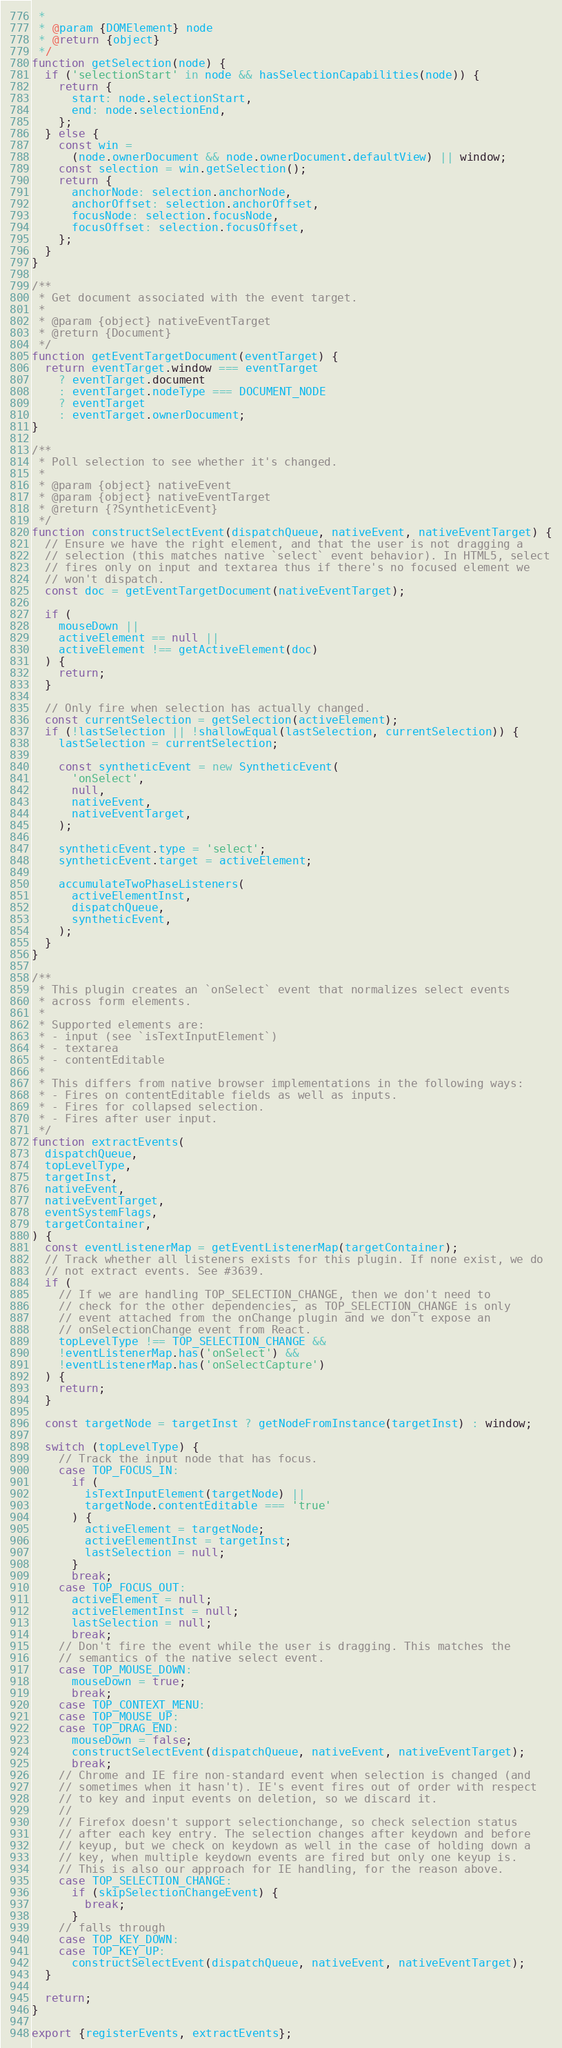Convert code to text. <code><loc_0><loc_0><loc_500><loc_500><_JavaScript_> *
 * @param {DOMElement} node
 * @return {object}
 */
function getSelection(node) {
  if ('selectionStart' in node && hasSelectionCapabilities(node)) {
    return {
      start: node.selectionStart,
      end: node.selectionEnd,
    };
  } else {
    const win =
      (node.ownerDocument && node.ownerDocument.defaultView) || window;
    const selection = win.getSelection();
    return {
      anchorNode: selection.anchorNode,
      anchorOffset: selection.anchorOffset,
      focusNode: selection.focusNode,
      focusOffset: selection.focusOffset,
    };
  }
}

/**
 * Get document associated with the event target.
 *
 * @param {object} nativeEventTarget
 * @return {Document}
 */
function getEventTargetDocument(eventTarget) {
  return eventTarget.window === eventTarget
    ? eventTarget.document
    : eventTarget.nodeType === DOCUMENT_NODE
    ? eventTarget
    : eventTarget.ownerDocument;
}

/**
 * Poll selection to see whether it's changed.
 *
 * @param {object} nativeEvent
 * @param {object} nativeEventTarget
 * @return {?SyntheticEvent}
 */
function constructSelectEvent(dispatchQueue, nativeEvent, nativeEventTarget) {
  // Ensure we have the right element, and that the user is not dragging a
  // selection (this matches native `select` event behavior). In HTML5, select
  // fires only on input and textarea thus if there's no focused element we
  // won't dispatch.
  const doc = getEventTargetDocument(nativeEventTarget);

  if (
    mouseDown ||
    activeElement == null ||
    activeElement !== getActiveElement(doc)
  ) {
    return;
  }

  // Only fire when selection has actually changed.
  const currentSelection = getSelection(activeElement);
  if (!lastSelection || !shallowEqual(lastSelection, currentSelection)) {
    lastSelection = currentSelection;

    const syntheticEvent = new SyntheticEvent(
      'onSelect',
      null,
      nativeEvent,
      nativeEventTarget,
    );

    syntheticEvent.type = 'select';
    syntheticEvent.target = activeElement;

    accumulateTwoPhaseListeners(
      activeElementInst,
      dispatchQueue,
      syntheticEvent,
    );
  }
}

/**
 * This plugin creates an `onSelect` event that normalizes select events
 * across form elements.
 *
 * Supported elements are:
 * - input (see `isTextInputElement`)
 * - textarea
 * - contentEditable
 *
 * This differs from native browser implementations in the following ways:
 * - Fires on contentEditable fields as well as inputs.
 * - Fires for collapsed selection.
 * - Fires after user input.
 */
function extractEvents(
  dispatchQueue,
  topLevelType,
  targetInst,
  nativeEvent,
  nativeEventTarget,
  eventSystemFlags,
  targetContainer,
) {
  const eventListenerMap = getEventListenerMap(targetContainer);
  // Track whether all listeners exists for this plugin. If none exist, we do
  // not extract events. See #3639.
  if (
    // If we are handling TOP_SELECTION_CHANGE, then we don't need to
    // check for the other dependencies, as TOP_SELECTION_CHANGE is only
    // event attached from the onChange plugin and we don't expose an
    // onSelectionChange event from React.
    topLevelType !== TOP_SELECTION_CHANGE &&
    !eventListenerMap.has('onSelect') &&
    !eventListenerMap.has('onSelectCapture')
  ) {
    return;
  }

  const targetNode = targetInst ? getNodeFromInstance(targetInst) : window;

  switch (topLevelType) {
    // Track the input node that has focus.
    case TOP_FOCUS_IN:
      if (
        isTextInputElement(targetNode) ||
        targetNode.contentEditable === 'true'
      ) {
        activeElement = targetNode;
        activeElementInst = targetInst;
        lastSelection = null;
      }
      break;
    case TOP_FOCUS_OUT:
      activeElement = null;
      activeElementInst = null;
      lastSelection = null;
      break;
    // Don't fire the event while the user is dragging. This matches the
    // semantics of the native select event.
    case TOP_MOUSE_DOWN:
      mouseDown = true;
      break;
    case TOP_CONTEXT_MENU:
    case TOP_MOUSE_UP:
    case TOP_DRAG_END:
      mouseDown = false;
      constructSelectEvent(dispatchQueue, nativeEvent, nativeEventTarget);
      break;
    // Chrome and IE fire non-standard event when selection is changed (and
    // sometimes when it hasn't). IE's event fires out of order with respect
    // to key and input events on deletion, so we discard it.
    //
    // Firefox doesn't support selectionchange, so check selection status
    // after each key entry. The selection changes after keydown and before
    // keyup, but we check on keydown as well in the case of holding down a
    // key, when multiple keydown events are fired but only one keyup is.
    // This is also our approach for IE handling, for the reason above.
    case TOP_SELECTION_CHANGE:
      if (skipSelectionChangeEvent) {
        break;
      }
    // falls through
    case TOP_KEY_DOWN:
    case TOP_KEY_UP:
      constructSelectEvent(dispatchQueue, nativeEvent, nativeEventTarget);
  }

  return;
}

export {registerEvents, extractEvents};
</code> 